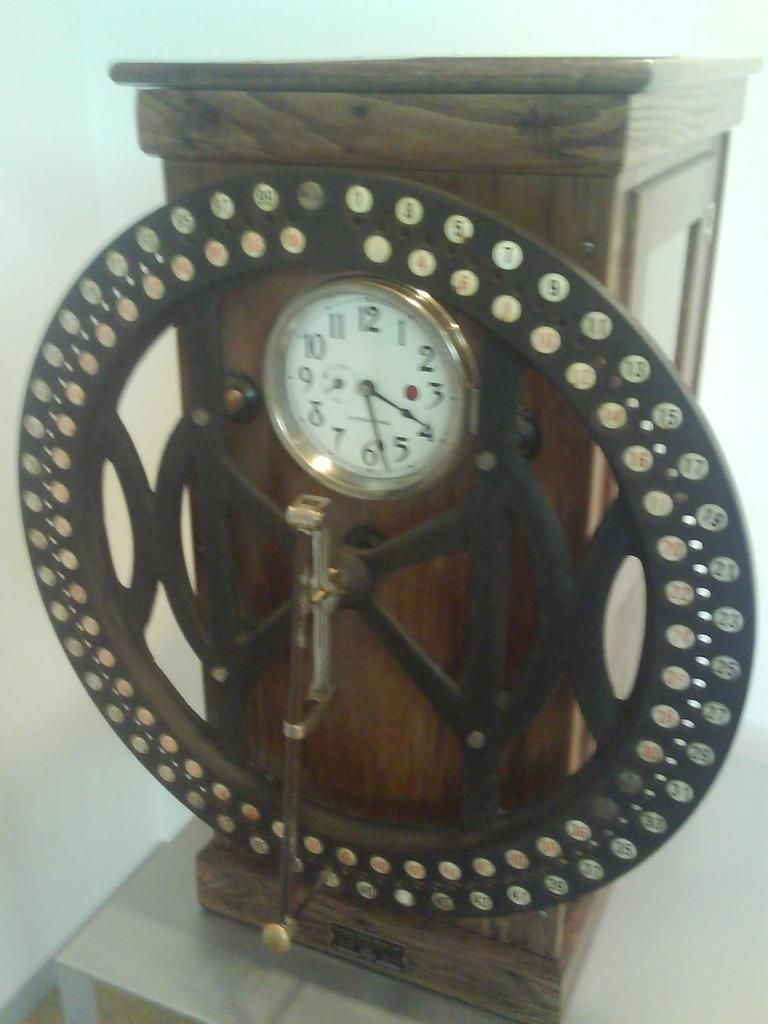<image>
Give a short and clear explanation of the subsequent image. A wooden clock has a small white face that shows the time is 4:29. 